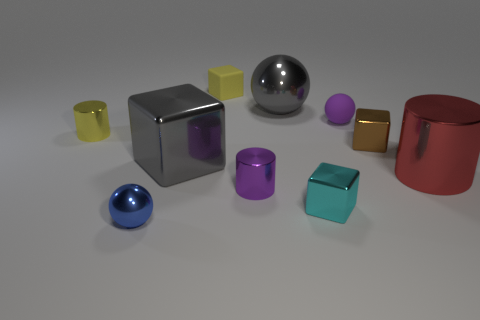Is the size of the cyan object the same as the thing that is left of the small blue sphere?
Your answer should be compact. Yes. There is a gray thing that is behind the tiny metal block that is behind the large metal cylinder; is there a tiny purple sphere right of it?
Give a very brief answer. Yes. What material is the cylinder to the left of the shiny thing in front of the tiny cyan thing made of?
Offer a very short reply. Metal. There is a thing that is both right of the yellow rubber thing and left of the large gray metallic sphere; what is its material?
Make the answer very short. Metal. Is there a purple metallic thing that has the same shape as the red object?
Ensure brevity in your answer.  Yes. Is there a small yellow rubber cube that is on the left side of the small ball that is in front of the large red thing?
Your answer should be compact. No. What number of other cylinders have the same material as the small purple cylinder?
Your answer should be very brief. 2. Are there any yellow cylinders?
Provide a short and direct response. Yes. What number of rubber things have the same color as the tiny metallic ball?
Your response must be concise. 0. Is the purple cylinder made of the same material as the big gray thing that is behind the brown metal block?
Offer a terse response. Yes. 